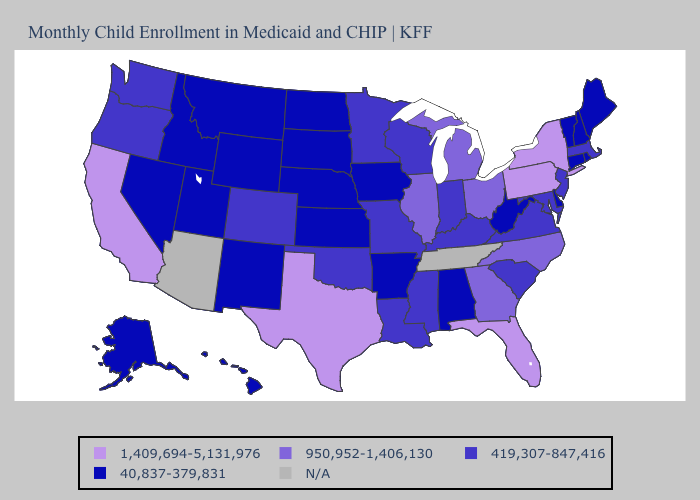Name the states that have a value in the range 1,409,694-5,131,976?
Short answer required. California, Florida, New York, Pennsylvania, Texas. What is the lowest value in the USA?
Keep it brief. 40,837-379,831. What is the value of Alaska?
Concise answer only. 40,837-379,831. Among the states that border Pennsylvania , does Delaware have the highest value?
Concise answer only. No. Among the states that border Texas , does Oklahoma have the lowest value?
Give a very brief answer. No. Does the first symbol in the legend represent the smallest category?
Keep it brief. No. What is the highest value in states that border North Dakota?
Concise answer only. 419,307-847,416. Name the states that have a value in the range 1,409,694-5,131,976?
Concise answer only. California, Florida, New York, Pennsylvania, Texas. Name the states that have a value in the range 950,952-1,406,130?
Answer briefly. Georgia, Illinois, Michigan, North Carolina, Ohio. Name the states that have a value in the range 950,952-1,406,130?
Keep it brief. Georgia, Illinois, Michigan, North Carolina, Ohio. What is the lowest value in states that border Maryland?
Quick response, please. 40,837-379,831. How many symbols are there in the legend?
Write a very short answer. 5. What is the value of South Carolina?
Concise answer only. 419,307-847,416. 